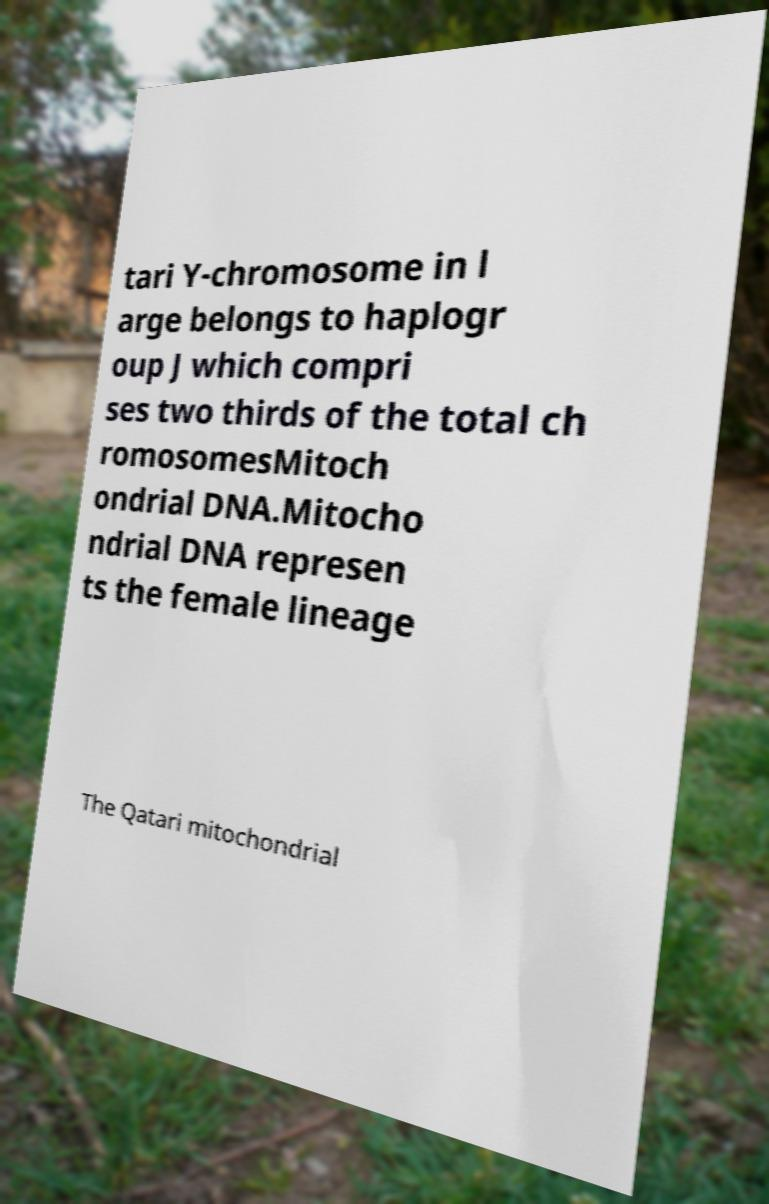Can you accurately transcribe the text from the provided image for me? tari Y-chromosome in l arge belongs to haplogr oup J which compri ses two thirds of the total ch romosomesMitoch ondrial DNA.Mitocho ndrial DNA represen ts the female lineage The Qatari mitochondrial 